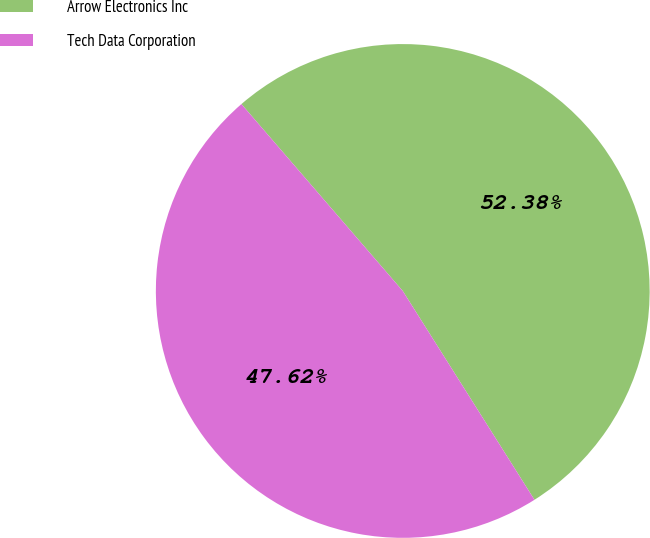<chart> <loc_0><loc_0><loc_500><loc_500><pie_chart><fcel>Arrow Electronics Inc<fcel>Tech Data Corporation<nl><fcel>52.38%<fcel>47.62%<nl></chart> 